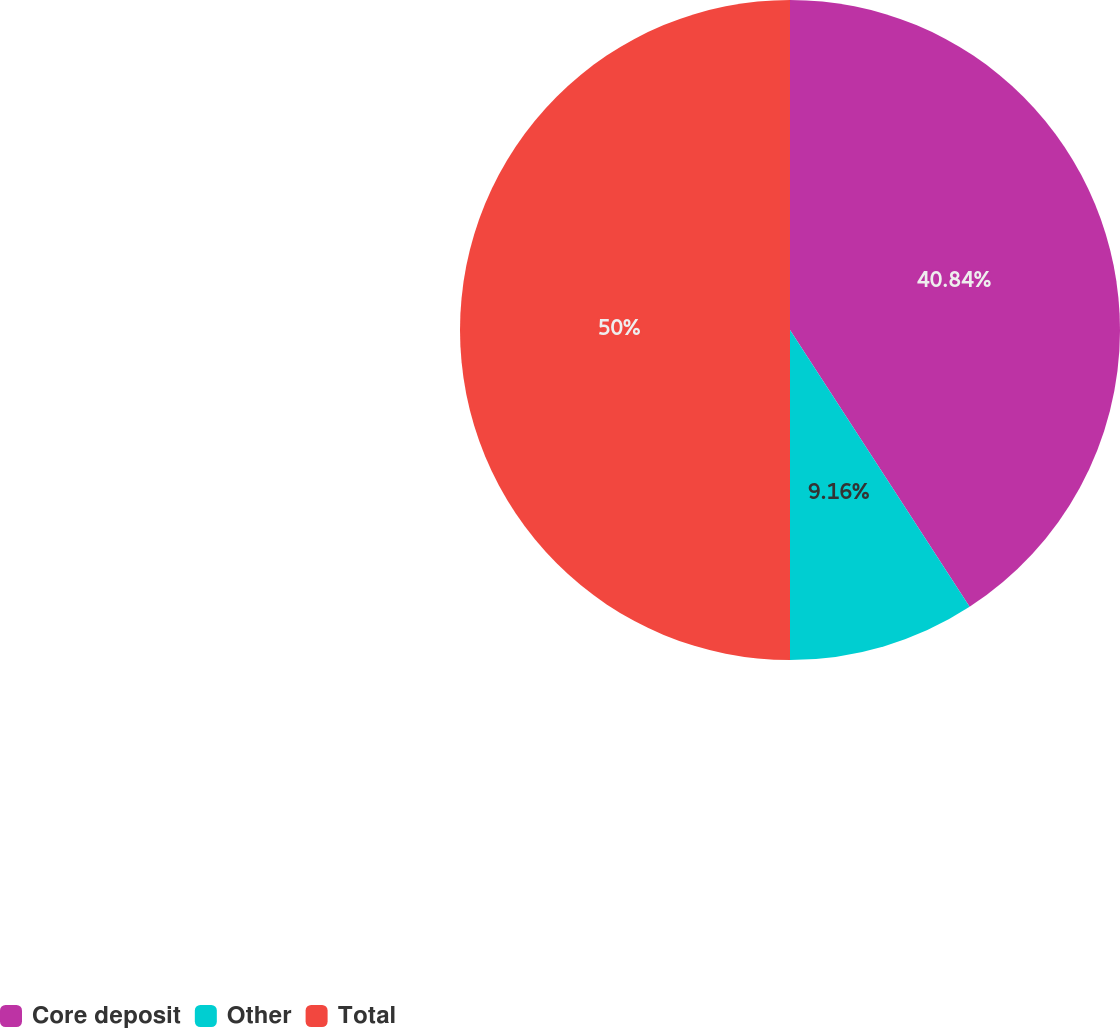Convert chart to OTSL. <chart><loc_0><loc_0><loc_500><loc_500><pie_chart><fcel>Core deposit<fcel>Other<fcel>Total<nl><fcel>40.84%<fcel>9.16%<fcel>50.0%<nl></chart> 